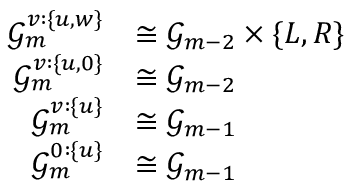<formula> <loc_0><loc_0><loc_500><loc_500>\begin{array} { r l } { \mathcal { G } _ { m } ^ { v \colon \{ u , w \} } } & { \cong \mathcal { G } _ { m - 2 } \times \{ L , R \} } \\ { \mathcal { G } _ { m } ^ { v \colon \{ u , 0 \} } } & { \cong \mathcal { G } _ { m - 2 } } \\ { \mathcal { G } _ { m } ^ { v \colon \{ u \} } } & { \cong \mathcal { G } _ { m - 1 } } \\ { \mathcal { G } _ { m } ^ { 0 \colon \{ u \} } } & { \cong \mathcal { G } _ { m - 1 } } \end{array}</formula> 